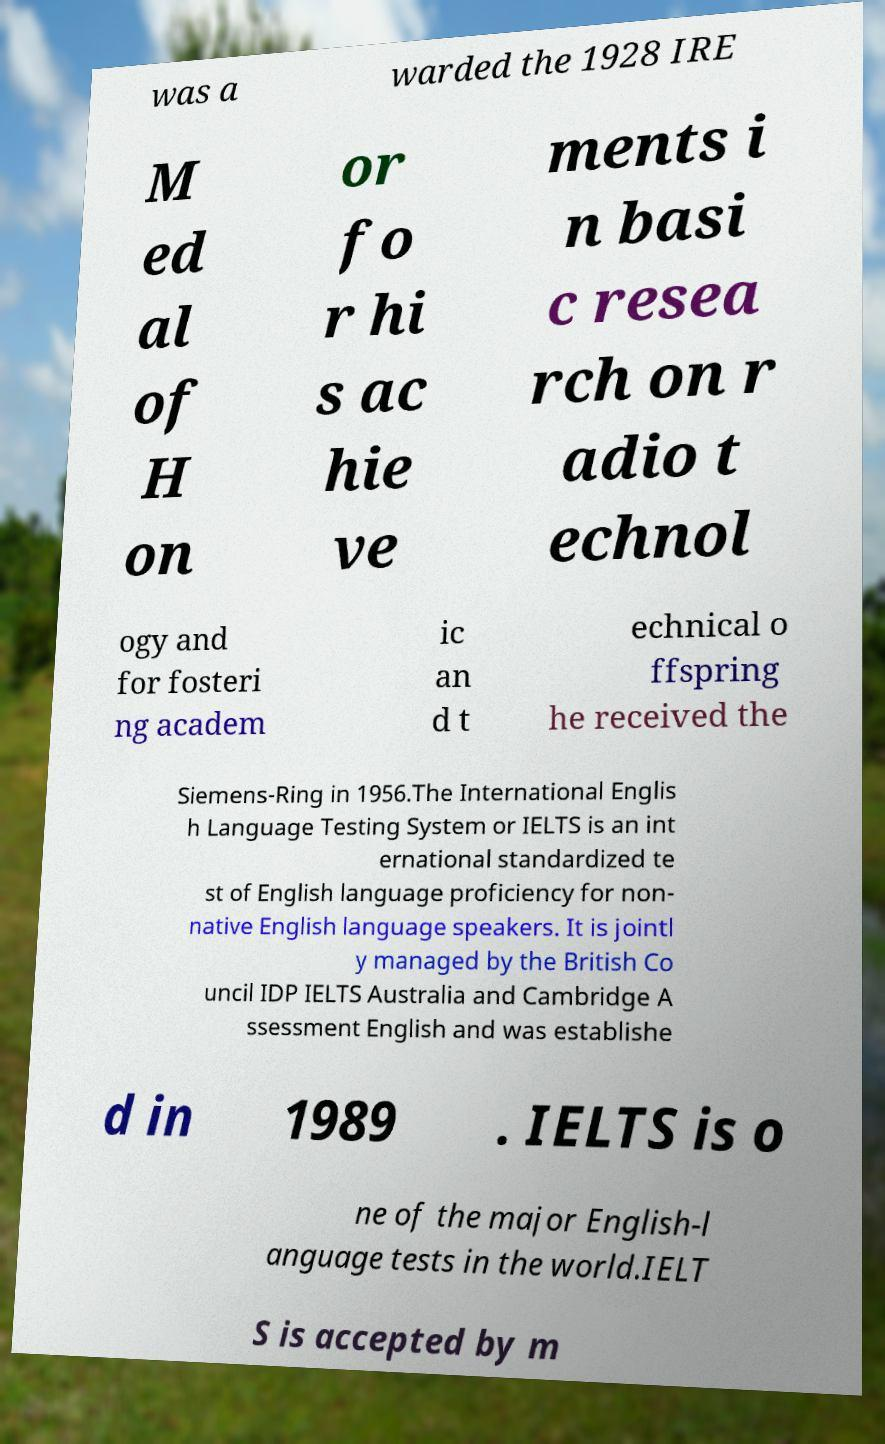Can you read and provide the text displayed in the image?This photo seems to have some interesting text. Can you extract and type it out for me? was a warded the 1928 IRE M ed al of H on or fo r hi s ac hie ve ments i n basi c resea rch on r adio t echnol ogy and for fosteri ng academ ic an d t echnical o ffspring he received the Siemens-Ring in 1956.The International Englis h Language Testing System or IELTS is an int ernational standardized te st of English language proficiency for non- native English language speakers. It is jointl y managed by the British Co uncil IDP IELTS Australia and Cambridge A ssessment English and was establishe d in 1989 . IELTS is o ne of the major English-l anguage tests in the world.IELT S is accepted by m 